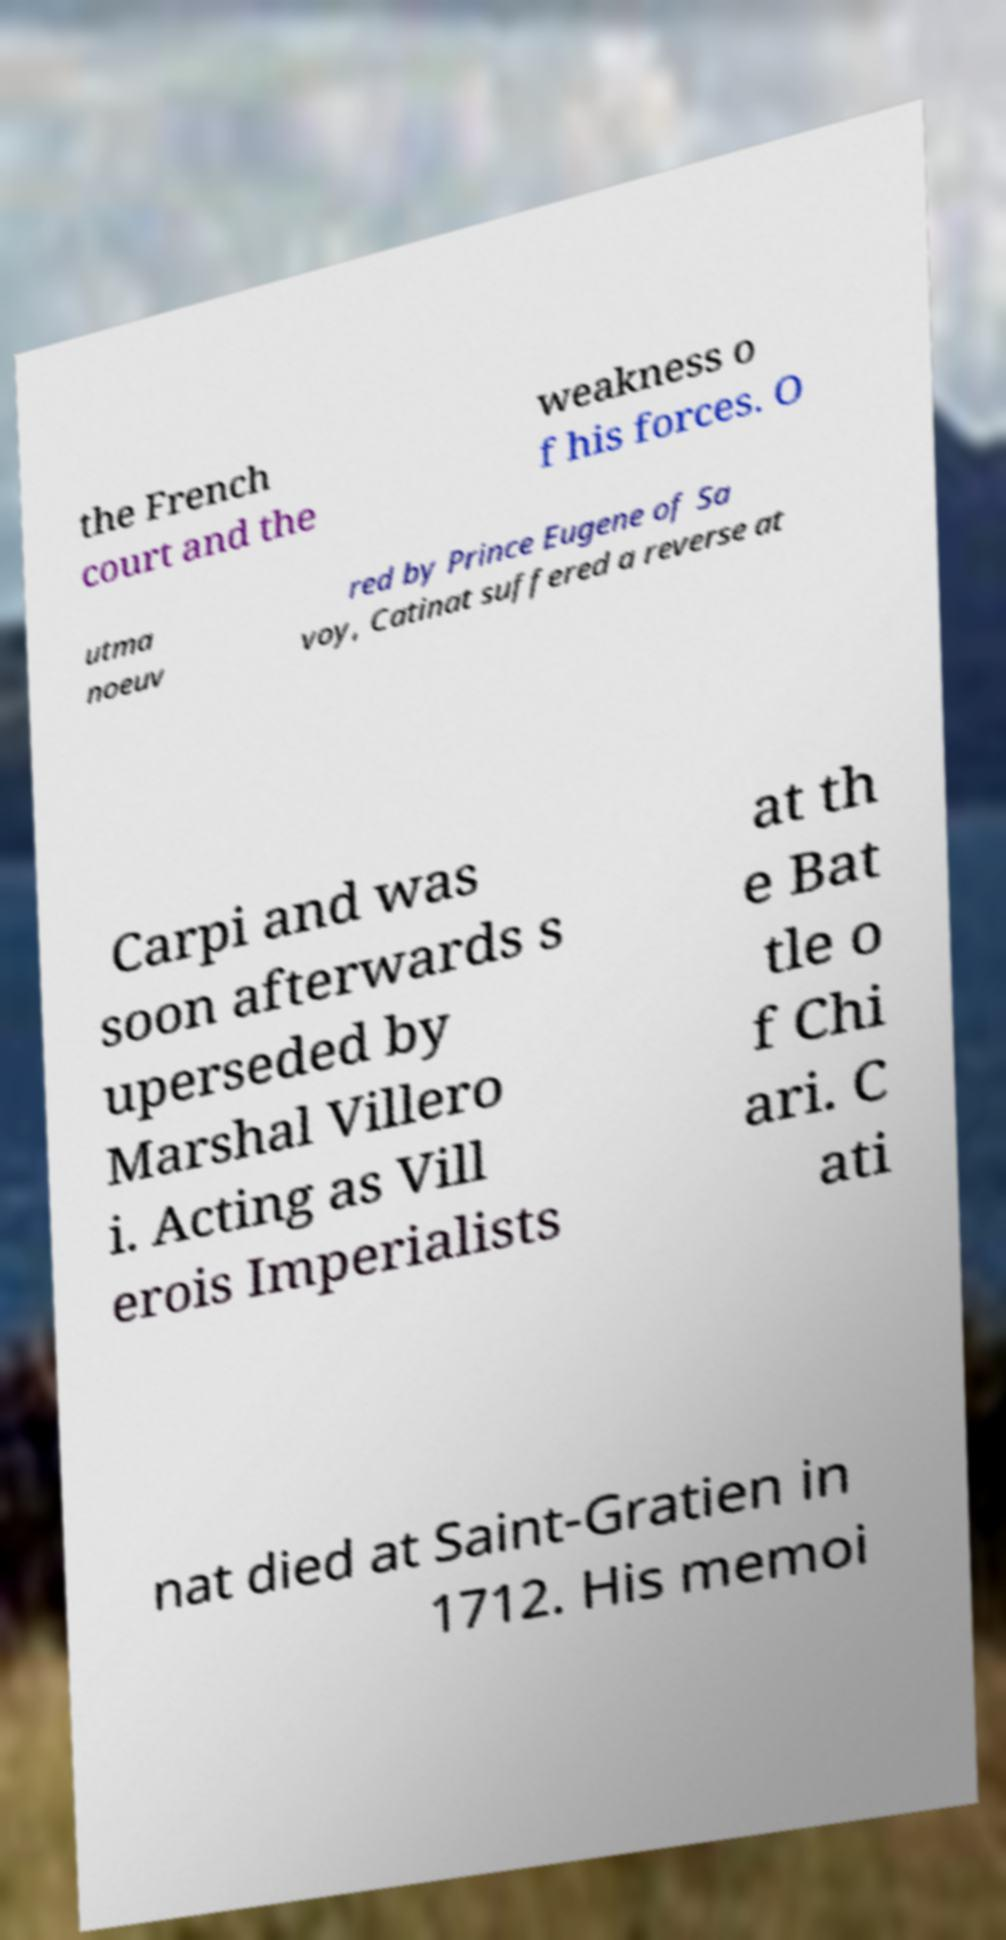Can you read and provide the text displayed in the image?This photo seems to have some interesting text. Can you extract and type it out for me? the French court and the weakness o f his forces. O utma noeuv red by Prince Eugene of Sa voy, Catinat suffered a reverse at Carpi and was soon afterwards s uperseded by Marshal Villero i. Acting as Vill erois Imperialists at th e Bat tle o f Chi ari. C ati nat died at Saint-Gratien in 1712. His memoi 